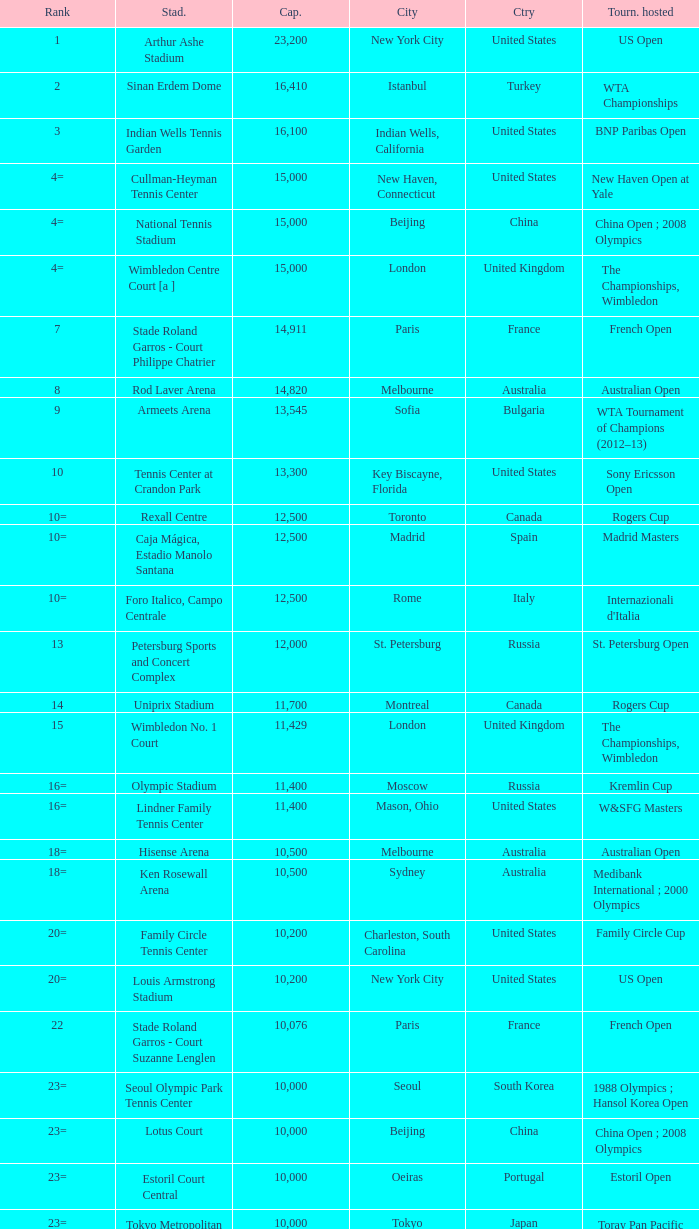What is the average capacity that has switzerland as the country? 6000.0. 